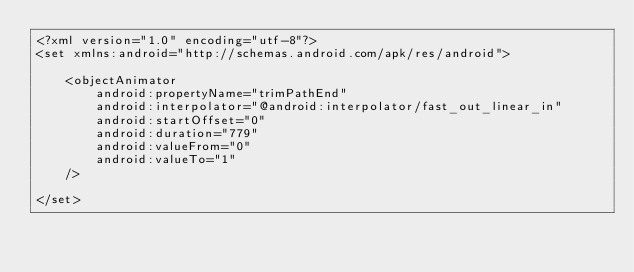<code> <loc_0><loc_0><loc_500><loc_500><_XML_><?xml version="1.0" encoding="utf-8"?>
<set xmlns:android="http://schemas.android.com/apk/res/android">

    <objectAnimator
        android:propertyName="trimPathEnd"
        android:interpolator="@android:interpolator/fast_out_linear_in"
        android:startOffset="0"
        android:duration="779"
        android:valueFrom="0"
        android:valueTo="1"
    />

</set></code> 